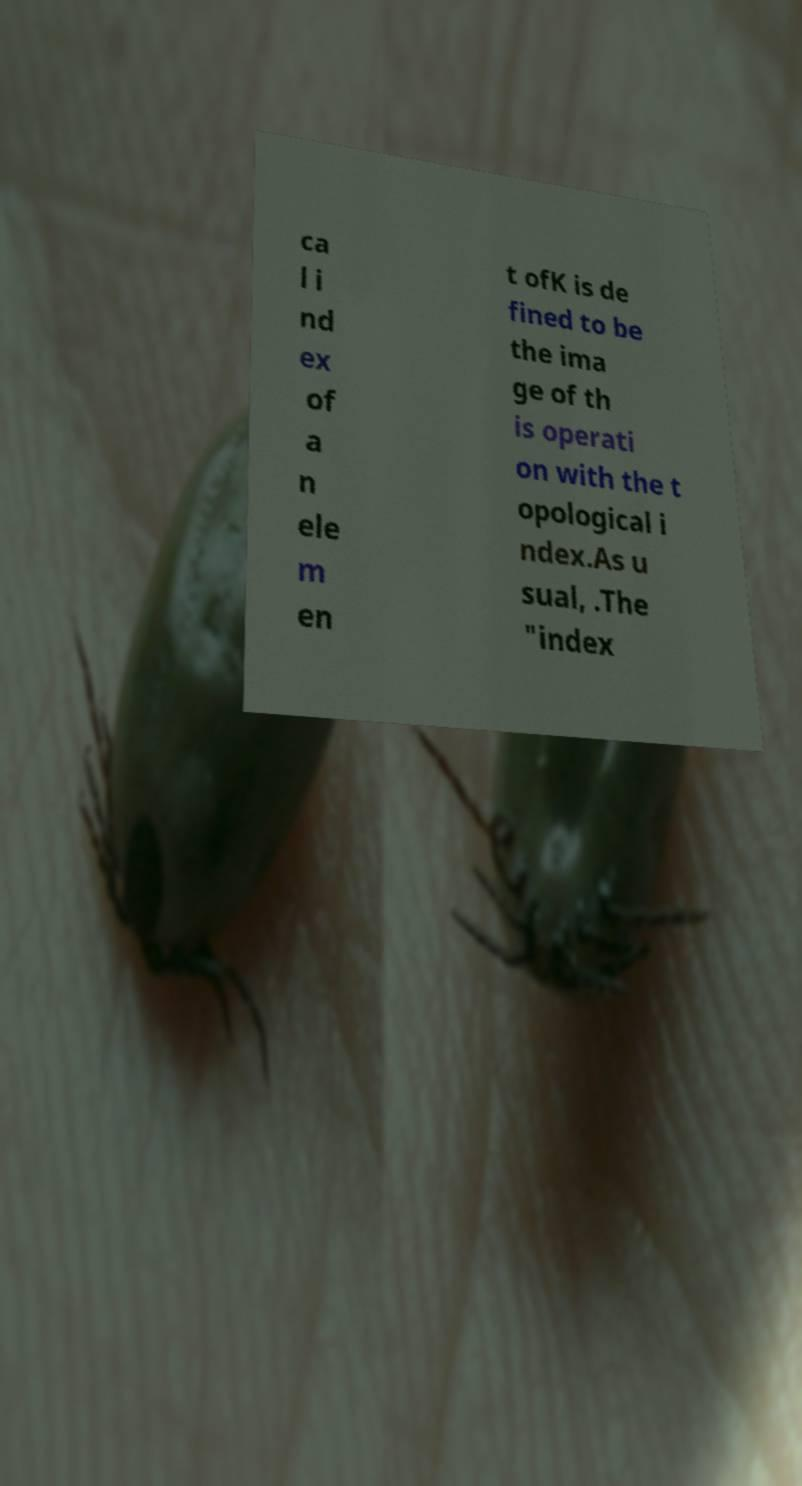Can you read and provide the text displayed in the image?This photo seems to have some interesting text. Can you extract and type it out for me? ca l i nd ex of a n ele m en t ofK is de fined to be the ima ge of th is operati on with the t opological i ndex.As u sual, .The "index 